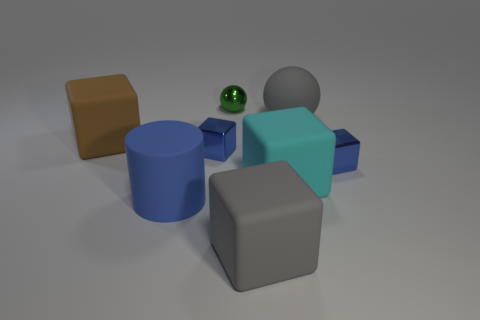Subtract all big gray cubes. How many cubes are left? 4 Add 2 big green metallic things. How many objects exist? 10 Subtract all gray spheres. How many spheres are left? 1 Subtract all cylinders. How many objects are left? 7 Subtract all gray blocks. Subtract all gray cylinders. How many blocks are left? 4 Subtract all brown spheres. How many blue blocks are left? 2 Subtract all gray rubber spheres. Subtract all brown cubes. How many objects are left? 6 Add 6 tiny blue cubes. How many tiny blue cubes are left? 8 Add 4 big objects. How many big objects exist? 9 Subtract 0 red cylinders. How many objects are left? 8 